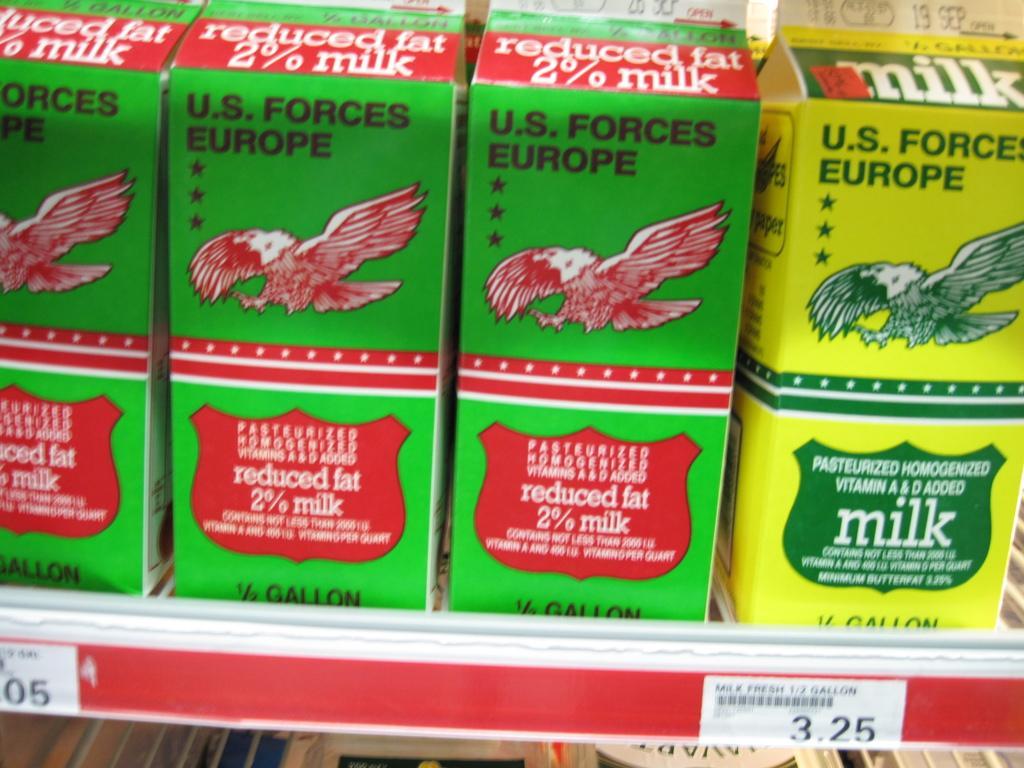How would you summarize this image in a sentence or two? In this image, we can see a shelf, on the shelf, we can see some boxes on which it is labelled as US LABELLED FORCES. 